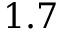<formula> <loc_0><loc_0><loc_500><loc_500>1 . 7</formula> 